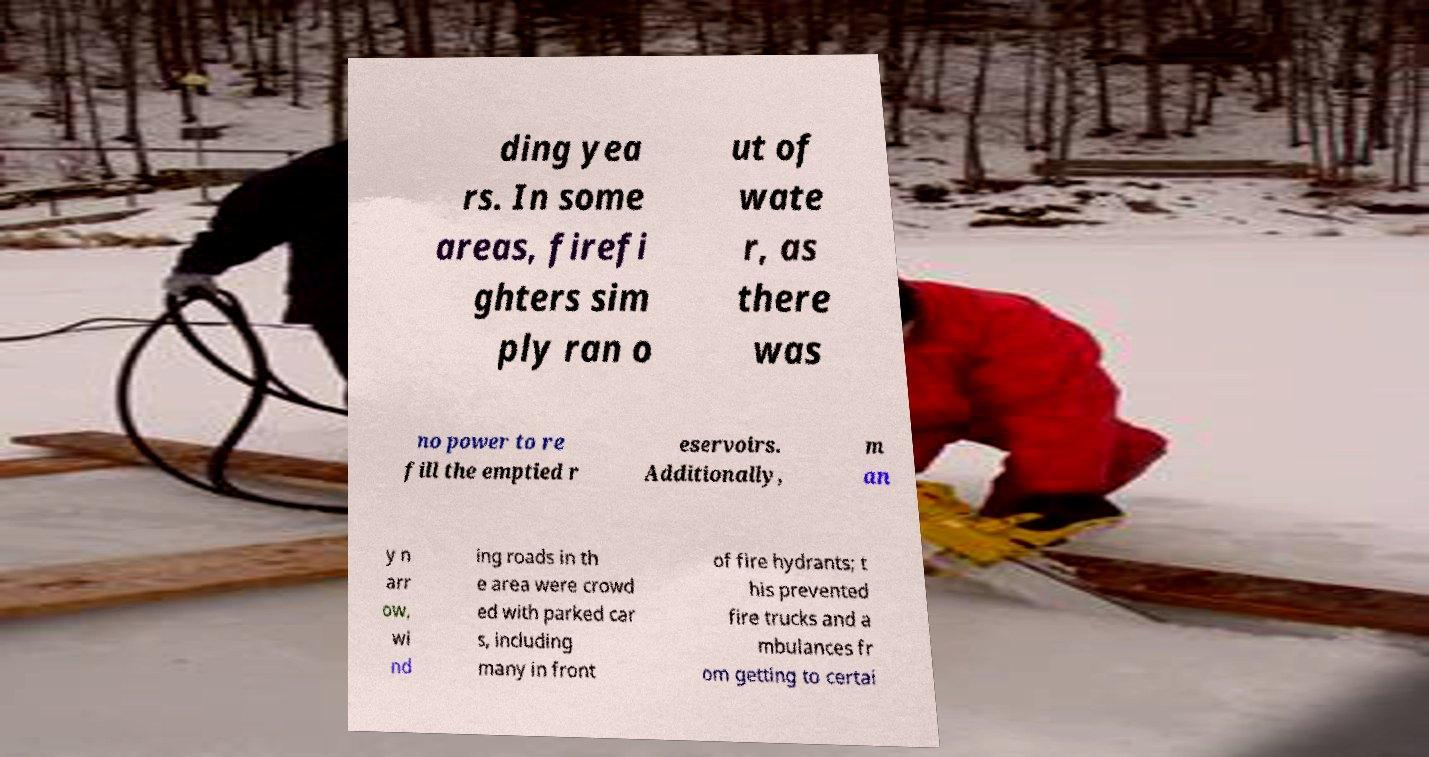Could you assist in decoding the text presented in this image and type it out clearly? ding yea rs. In some areas, firefi ghters sim ply ran o ut of wate r, as there was no power to re fill the emptied r eservoirs. Additionally, m an y n arr ow, wi nd ing roads in th e area were crowd ed with parked car s, including many in front of fire hydrants; t his prevented fire trucks and a mbulances fr om getting to certai 